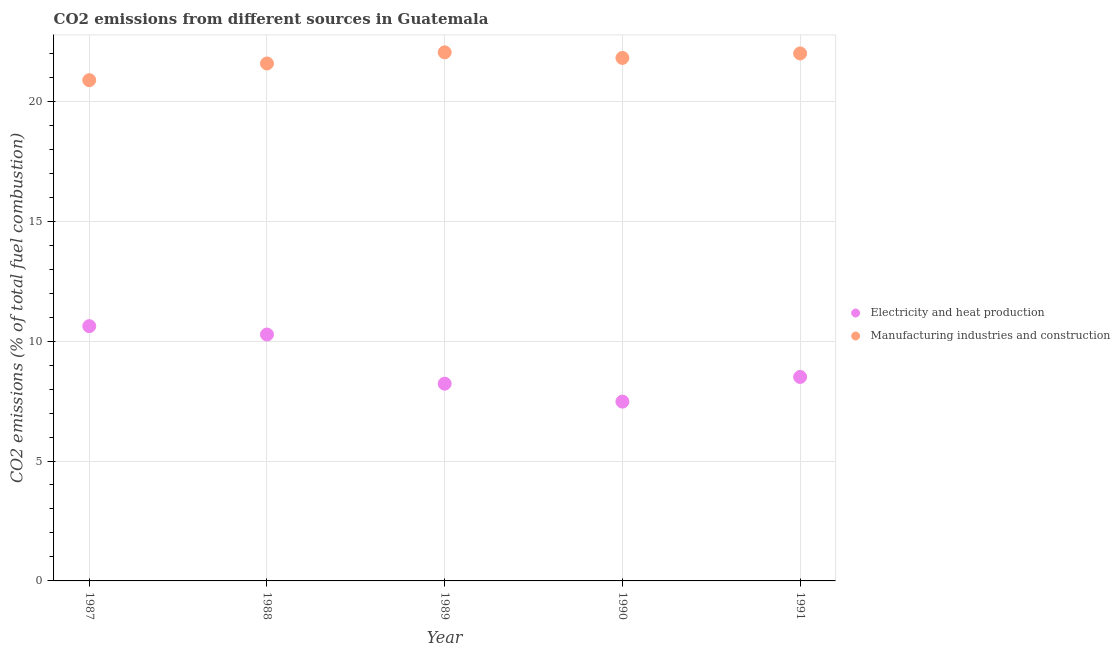How many different coloured dotlines are there?
Make the answer very short. 2. What is the co2 emissions due to electricity and heat production in 1991?
Offer a very short reply. 8.5. Across all years, what is the maximum co2 emissions due to electricity and heat production?
Offer a very short reply. 10.62. Across all years, what is the minimum co2 emissions due to electricity and heat production?
Offer a very short reply. 7.48. What is the total co2 emissions due to electricity and heat production in the graph?
Give a very brief answer. 45.1. What is the difference between the co2 emissions due to manufacturing industries in 1988 and that in 1990?
Offer a terse response. -0.23. What is the difference between the co2 emissions due to manufacturing industries in 1990 and the co2 emissions due to electricity and heat production in 1991?
Ensure brevity in your answer.  13.3. What is the average co2 emissions due to electricity and heat production per year?
Keep it short and to the point. 9.02. In the year 1988, what is the difference between the co2 emissions due to electricity and heat production and co2 emissions due to manufacturing industries?
Your answer should be compact. -11.3. What is the ratio of the co2 emissions due to electricity and heat production in 1987 to that in 1988?
Offer a terse response. 1.03. Is the co2 emissions due to electricity and heat production in 1988 less than that in 1989?
Make the answer very short. No. What is the difference between the highest and the second highest co2 emissions due to electricity and heat production?
Your response must be concise. 0.35. What is the difference between the highest and the lowest co2 emissions due to electricity and heat production?
Keep it short and to the point. 3.15. In how many years, is the co2 emissions due to electricity and heat production greater than the average co2 emissions due to electricity and heat production taken over all years?
Ensure brevity in your answer.  2. Is the sum of the co2 emissions due to manufacturing industries in 1987 and 1988 greater than the maximum co2 emissions due to electricity and heat production across all years?
Provide a succinct answer. Yes. Is the co2 emissions due to electricity and heat production strictly less than the co2 emissions due to manufacturing industries over the years?
Your answer should be very brief. Yes. How many years are there in the graph?
Keep it short and to the point. 5. Are the values on the major ticks of Y-axis written in scientific E-notation?
Provide a short and direct response. No. Does the graph contain any zero values?
Provide a short and direct response. No. What is the title of the graph?
Ensure brevity in your answer.  CO2 emissions from different sources in Guatemala. Does "Non-solid fuel" appear as one of the legend labels in the graph?
Your answer should be very brief. No. What is the label or title of the X-axis?
Provide a succinct answer. Year. What is the label or title of the Y-axis?
Your response must be concise. CO2 emissions (% of total fuel combustion). What is the CO2 emissions (% of total fuel combustion) in Electricity and heat production in 1987?
Ensure brevity in your answer.  10.62. What is the CO2 emissions (% of total fuel combustion) in Manufacturing industries and construction in 1987?
Ensure brevity in your answer.  20.88. What is the CO2 emissions (% of total fuel combustion) of Electricity and heat production in 1988?
Ensure brevity in your answer.  10.27. What is the CO2 emissions (% of total fuel combustion) of Manufacturing industries and construction in 1988?
Your answer should be very brief. 21.58. What is the CO2 emissions (% of total fuel combustion) of Electricity and heat production in 1989?
Make the answer very short. 8.22. What is the CO2 emissions (% of total fuel combustion) of Manufacturing industries and construction in 1989?
Your response must be concise. 22.04. What is the CO2 emissions (% of total fuel combustion) in Electricity and heat production in 1990?
Keep it short and to the point. 7.48. What is the CO2 emissions (% of total fuel combustion) of Manufacturing industries and construction in 1990?
Ensure brevity in your answer.  21.81. What is the CO2 emissions (% of total fuel combustion) of Electricity and heat production in 1991?
Ensure brevity in your answer.  8.5. What is the CO2 emissions (% of total fuel combustion) of Manufacturing industries and construction in 1991?
Your answer should be very brief. 21.99. Across all years, what is the maximum CO2 emissions (% of total fuel combustion) of Electricity and heat production?
Give a very brief answer. 10.62. Across all years, what is the maximum CO2 emissions (% of total fuel combustion) in Manufacturing industries and construction?
Provide a short and direct response. 22.04. Across all years, what is the minimum CO2 emissions (% of total fuel combustion) in Electricity and heat production?
Your answer should be very brief. 7.48. Across all years, what is the minimum CO2 emissions (% of total fuel combustion) of Manufacturing industries and construction?
Your response must be concise. 20.88. What is the total CO2 emissions (% of total fuel combustion) of Electricity and heat production in the graph?
Make the answer very short. 45.1. What is the total CO2 emissions (% of total fuel combustion) in Manufacturing industries and construction in the graph?
Provide a succinct answer. 108.29. What is the difference between the CO2 emissions (% of total fuel combustion) of Electricity and heat production in 1987 and that in 1988?
Make the answer very short. 0.35. What is the difference between the CO2 emissions (% of total fuel combustion) in Manufacturing industries and construction in 1987 and that in 1988?
Offer a terse response. -0.7. What is the difference between the CO2 emissions (% of total fuel combustion) of Electricity and heat production in 1987 and that in 1989?
Provide a succinct answer. 2.4. What is the difference between the CO2 emissions (% of total fuel combustion) in Manufacturing industries and construction in 1987 and that in 1989?
Offer a terse response. -1.16. What is the difference between the CO2 emissions (% of total fuel combustion) in Electricity and heat production in 1987 and that in 1990?
Provide a succinct answer. 3.15. What is the difference between the CO2 emissions (% of total fuel combustion) of Manufacturing industries and construction in 1987 and that in 1990?
Ensure brevity in your answer.  -0.93. What is the difference between the CO2 emissions (% of total fuel combustion) in Electricity and heat production in 1987 and that in 1991?
Your response must be concise. 2.12. What is the difference between the CO2 emissions (% of total fuel combustion) in Manufacturing industries and construction in 1987 and that in 1991?
Make the answer very short. -1.11. What is the difference between the CO2 emissions (% of total fuel combustion) in Electricity and heat production in 1988 and that in 1989?
Provide a short and direct response. 2.05. What is the difference between the CO2 emissions (% of total fuel combustion) of Manufacturing industries and construction in 1988 and that in 1989?
Ensure brevity in your answer.  -0.46. What is the difference between the CO2 emissions (% of total fuel combustion) in Electricity and heat production in 1988 and that in 1990?
Make the answer very short. 2.8. What is the difference between the CO2 emissions (% of total fuel combustion) in Manufacturing industries and construction in 1988 and that in 1990?
Give a very brief answer. -0.23. What is the difference between the CO2 emissions (% of total fuel combustion) in Electricity and heat production in 1988 and that in 1991?
Offer a very short reply. 1.77. What is the difference between the CO2 emissions (% of total fuel combustion) in Manufacturing industries and construction in 1988 and that in 1991?
Your response must be concise. -0.42. What is the difference between the CO2 emissions (% of total fuel combustion) in Electricity and heat production in 1989 and that in 1990?
Provide a short and direct response. 0.75. What is the difference between the CO2 emissions (% of total fuel combustion) of Manufacturing industries and construction in 1989 and that in 1990?
Your answer should be very brief. 0.23. What is the difference between the CO2 emissions (% of total fuel combustion) of Electricity and heat production in 1989 and that in 1991?
Provide a short and direct response. -0.28. What is the difference between the CO2 emissions (% of total fuel combustion) in Manufacturing industries and construction in 1989 and that in 1991?
Offer a very short reply. 0.05. What is the difference between the CO2 emissions (% of total fuel combustion) in Electricity and heat production in 1990 and that in 1991?
Keep it short and to the point. -1.03. What is the difference between the CO2 emissions (% of total fuel combustion) of Manufacturing industries and construction in 1990 and that in 1991?
Provide a succinct answer. -0.19. What is the difference between the CO2 emissions (% of total fuel combustion) in Electricity and heat production in 1987 and the CO2 emissions (% of total fuel combustion) in Manufacturing industries and construction in 1988?
Keep it short and to the point. -10.95. What is the difference between the CO2 emissions (% of total fuel combustion) of Electricity and heat production in 1987 and the CO2 emissions (% of total fuel combustion) of Manufacturing industries and construction in 1989?
Offer a terse response. -11.42. What is the difference between the CO2 emissions (% of total fuel combustion) in Electricity and heat production in 1987 and the CO2 emissions (% of total fuel combustion) in Manufacturing industries and construction in 1990?
Keep it short and to the point. -11.18. What is the difference between the CO2 emissions (% of total fuel combustion) of Electricity and heat production in 1987 and the CO2 emissions (% of total fuel combustion) of Manufacturing industries and construction in 1991?
Offer a terse response. -11.37. What is the difference between the CO2 emissions (% of total fuel combustion) of Electricity and heat production in 1988 and the CO2 emissions (% of total fuel combustion) of Manufacturing industries and construction in 1989?
Ensure brevity in your answer.  -11.77. What is the difference between the CO2 emissions (% of total fuel combustion) in Electricity and heat production in 1988 and the CO2 emissions (% of total fuel combustion) in Manufacturing industries and construction in 1990?
Your answer should be compact. -11.53. What is the difference between the CO2 emissions (% of total fuel combustion) in Electricity and heat production in 1988 and the CO2 emissions (% of total fuel combustion) in Manufacturing industries and construction in 1991?
Provide a succinct answer. -11.72. What is the difference between the CO2 emissions (% of total fuel combustion) of Electricity and heat production in 1989 and the CO2 emissions (% of total fuel combustion) of Manufacturing industries and construction in 1990?
Make the answer very short. -13.58. What is the difference between the CO2 emissions (% of total fuel combustion) in Electricity and heat production in 1989 and the CO2 emissions (% of total fuel combustion) in Manufacturing industries and construction in 1991?
Your response must be concise. -13.77. What is the difference between the CO2 emissions (% of total fuel combustion) in Electricity and heat production in 1990 and the CO2 emissions (% of total fuel combustion) in Manufacturing industries and construction in 1991?
Give a very brief answer. -14.52. What is the average CO2 emissions (% of total fuel combustion) in Electricity and heat production per year?
Your answer should be very brief. 9.02. What is the average CO2 emissions (% of total fuel combustion) of Manufacturing industries and construction per year?
Your response must be concise. 21.66. In the year 1987, what is the difference between the CO2 emissions (% of total fuel combustion) of Electricity and heat production and CO2 emissions (% of total fuel combustion) of Manufacturing industries and construction?
Give a very brief answer. -10.26. In the year 1988, what is the difference between the CO2 emissions (% of total fuel combustion) of Electricity and heat production and CO2 emissions (% of total fuel combustion) of Manufacturing industries and construction?
Your response must be concise. -11.3. In the year 1989, what is the difference between the CO2 emissions (% of total fuel combustion) of Electricity and heat production and CO2 emissions (% of total fuel combustion) of Manufacturing industries and construction?
Your answer should be compact. -13.82. In the year 1990, what is the difference between the CO2 emissions (% of total fuel combustion) of Electricity and heat production and CO2 emissions (% of total fuel combustion) of Manufacturing industries and construction?
Provide a succinct answer. -14.33. In the year 1991, what is the difference between the CO2 emissions (% of total fuel combustion) of Electricity and heat production and CO2 emissions (% of total fuel combustion) of Manufacturing industries and construction?
Your response must be concise. -13.49. What is the ratio of the CO2 emissions (% of total fuel combustion) of Electricity and heat production in 1987 to that in 1988?
Keep it short and to the point. 1.03. What is the ratio of the CO2 emissions (% of total fuel combustion) of Manufacturing industries and construction in 1987 to that in 1988?
Give a very brief answer. 0.97. What is the ratio of the CO2 emissions (% of total fuel combustion) of Electricity and heat production in 1987 to that in 1989?
Give a very brief answer. 1.29. What is the ratio of the CO2 emissions (% of total fuel combustion) in Manufacturing industries and construction in 1987 to that in 1989?
Give a very brief answer. 0.95. What is the ratio of the CO2 emissions (% of total fuel combustion) of Electricity and heat production in 1987 to that in 1990?
Ensure brevity in your answer.  1.42. What is the ratio of the CO2 emissions (% of total fuel combustion) in Manufacturing industries and construction in 1987 to that in 1990?
Make the answer very short. 0.96. What is the ratio of the CO2 emissions (% of total fuel combustion) of Electricity and heat production in 1987 to that in 1991?
Your response must be concise. 1.25. What is the ratio of the CO2 emissions (% of total fuel combustion) in Manufacturing industries and construction in 1987 to that in 1991?
Your answer should be compact. 0.95. What is the ratio of the CO2 emissions (% of total fuel combustion) of Electricity and heat production in 1988 to that in 1989?
Your answer should be very brief. 1.25. What is the ratio of the CO2 emissions (% of total fuel combustion) of Manufacturing industries and construction in 1988 to that in 1989?
Provide a short and direct response. 0.98. What is the ratio of the CO2 emissions (% of total fuel combustion) in Electricity and heat production in 1988 to that in 1990?
Your response must be concise. 1.37. What is the ratio of the CO2 emissions (% of total fuel combustion) in Manufacturing industries and construction in 1988 to that in 1990?
Your answer should be compact. 0.99. What is the ratio of the CO2 emissions (% of total fuel combustion) in Electricity and heat production in 1988 to that in 1991?
Offer a terse response. 1.21. What is the ratio of the CO2 emissions (% of total fuel combustion) of Electricity and heat production in 1989 to that in 1990?
Your answer should be compact. 1.1. What is the ratio of the CO2 emissions (% of total fuel combustion) of Manufacturing industries and construction in 1989 to that in 1990?
Your answer should be compact. 1.01. What is the ratio of the CO2 emissions (% of total fuel combustion) in Manufacturing industries and construction in 1989 to that in 1991?
Provide a short and direct response. 1. What is the ratio of the CO2 emissions (% of total fuel combustion) of Electricity and heat production in 1990 to that in 1991?
Provide a short and direct response. 0.88. What is the difference between the highest and the second highest CO2 emissions (% of total fuel combustion) of Electricity and heat production?
Offer a terse response. 0.35. What is the difference between the highest and the second highest CO2 emissions (% of total fuel combustion) in Manufacturing industries and construction?
Your answer should be compact. 0.05. What is the difference between the highest and the lowest CO2 emissions (% of total fuel combustion) in Electricity and heat production?
Provide a succinct answer. 3.15. What is the difference between the highest and the lowest CO2 emissions (% of total fuel combustion) in Manufacturing industries and construction?
Offer a very short reply. 1.16. 